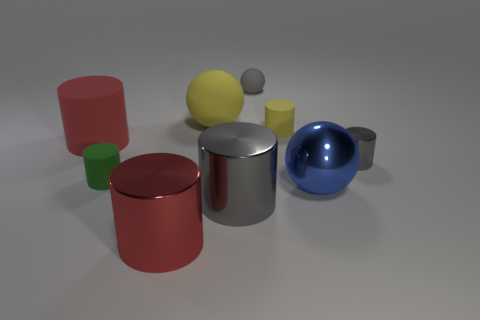Subtract all big balls. How many balls are left? 1 Add 1 yellow things. How many objects exist? 10 Subtract all yellow cylinders. How many cylinders are left? 5 Subtract all red cylinders. Subtract all blue blocks. How many cylinders are left? 4 Subtract all spheres. How many objects are left? 6 Add 6 blue metallic spheres. How many blue metallic spheres exist? 7 Subtract 1 blue spheres. How many objects are left? 8 Subtract all small objects. Subtract all big matte objects. How many objects are left? 3 Add 9 big matte cylinders. How many big matte cylinders are left? 10 